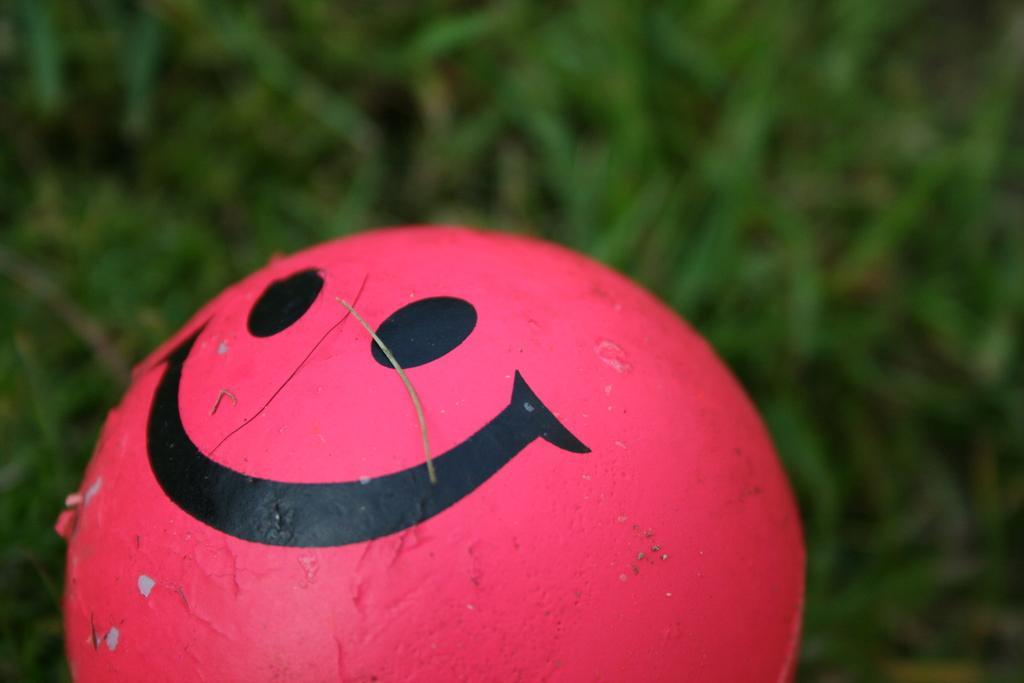Describe this image in one or two sentences. In the center of the image we can see a smiley ball which is in red color and the background is blurred with the grass. 